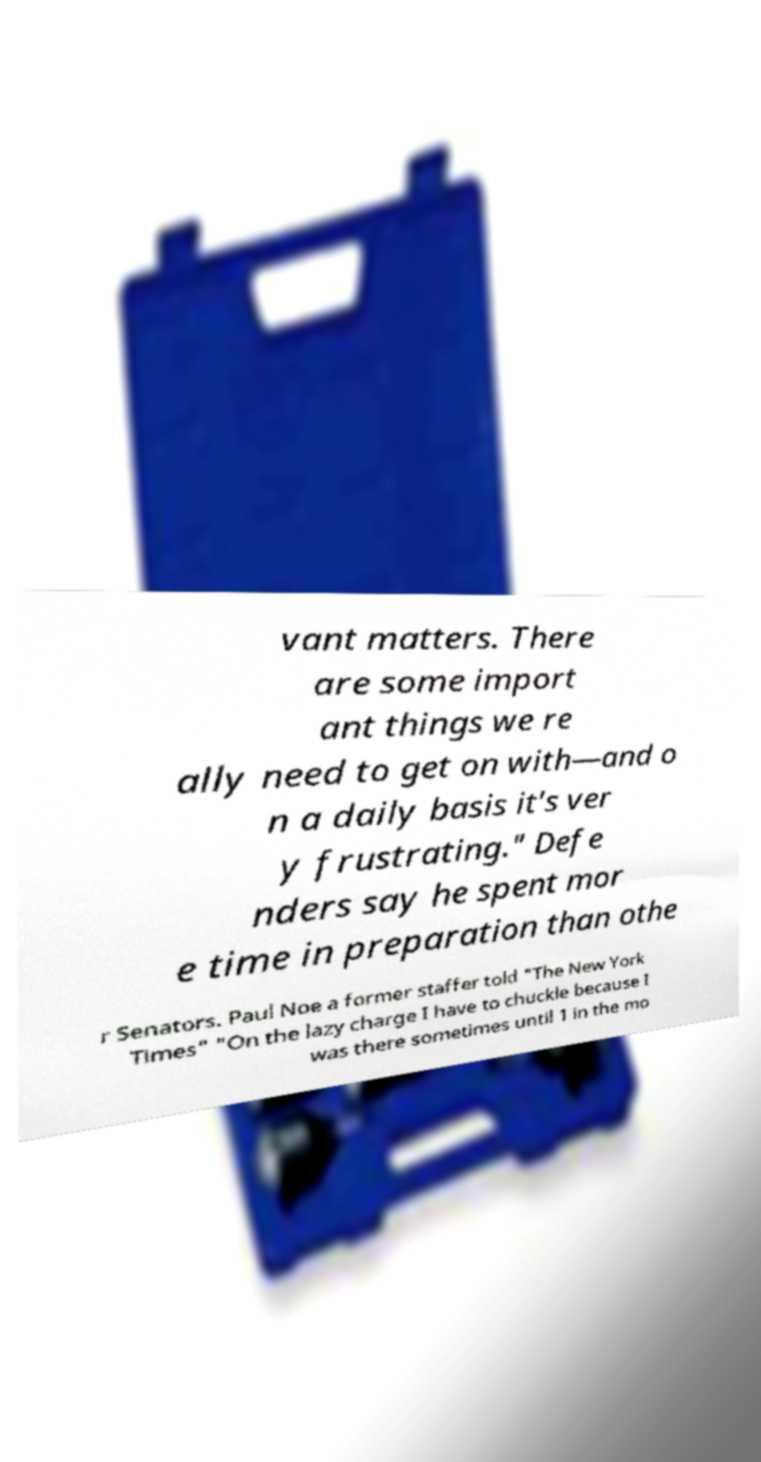I need the written content from this picture converted into text. Can you do that? vant matters. There are some import ant things we re ally need to get on with—and o n a daily basis it's ver y frustrating." Defe nders say he spent mor e time in preparation than othe r Senators. Paul Noe a former staffer told "The New York Times" "On the lazy charge I have to chuckle because I was there sometimes until 1 in the mo 